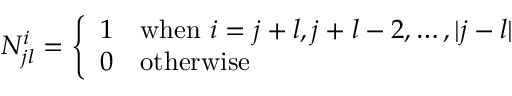Convert formula to latex. <formula><loc_0><loc_0><loc_500><loc_500>N _ { j l } ^ { i } = \left \{ \begin{array} { l l } { 1 } & { w h e n i = j + l , j + l - 2 , \dots , | j - l | } \\ { 0 } & { o t h e r w i s e } \end{array}</formula> 